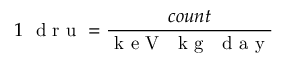Convert formula to latex. <formula><loc_0><loc_0><loc_500><loc_500>1 d r u = \frac { c o u n t } { k e V k g d a y }</formula> 